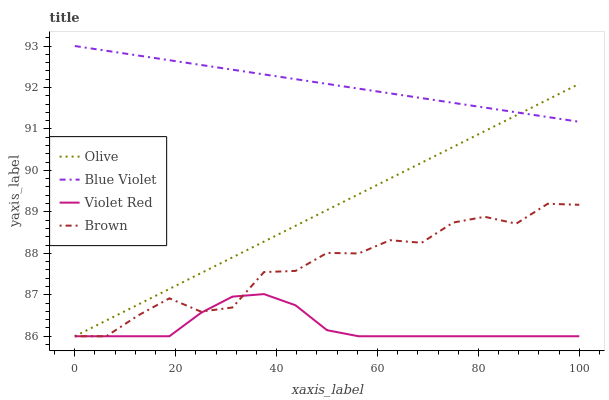Does Brown have the minimum area under the curve?
Answer yes or no. No. Does Brown have the maximum area under the curve?
Answer yes or no. No. Is Violet Red the smoothest?
Answer yes or no. No. Is Violet Red the roughest?
Answer yes or no. No. Does Blue Violet have the lowest value?
Answer yes or no. No. Does Brown have the highest value?
Answer yes or no. No. Is Violet Red less than Blue Violet?
Answer yes or no. Yes. Is Blue Violet greater than Violet Red?
Answer yes or no. Yes. Does Violet Red intersect Blue Violet?
Answer yes or no. No. 